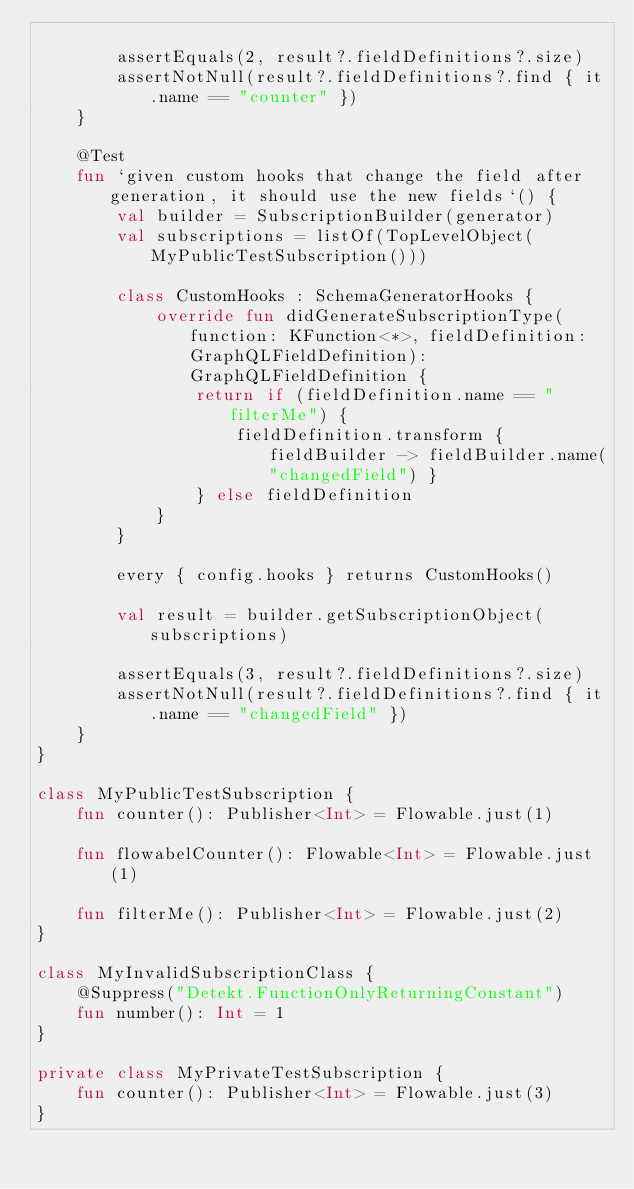<code> <loc_0><loc_0><loc_500><loc_500><_Kotlin_>
        assertEquals(2, result?.fieldDefinitions?.size)
        assertNotNull(result?.fieldDefinitions?.find { it.name == "counter" })
    }

    @Test
    fun `given custom hooks that change the field after generation, it should use the new fields`() {
        val builder = SubscriptionBuilder(generator)
        val subscriptions = listOf(TopLevelObject(MyPublicTestSubscription()))

        class CustomHooks : SchemaGeneratorHooks {
            override fun didGenerateSubscriptionType(function: KFunction<*>, fieldDefinition: GraphQLFieldDefinition): GraphQLFieldDefinition {
                return if (fieldDefinition.name == "filterMe") {
                    fieldDefinition.transform { fieldBuilder -> fieldBuilder.name("changedField") }
                } else fieldDefinition
            }
        }

        every { config.hooks } returns CustomHooks()

        val result = builder.getSubscriptionObject(subscriptions)

        assertEquals(3, result?.fieldDefinitions?.size)
        assertNotNull(result?.fieldDefinitions?.find { it.name == "changedField" })
    }
}

class MyPublicTestSubscription {
    fun counter(): Publisher<Int> = Flowable.just(1)

    fun flowabelCounter(): Flowable<Int> = Flowable.just(1)

    fun filterMe(): Publisher<Int> = Flowable.just(2)
}

class MyInvalidSubscriptionClass {
    @Suppress("Detekt.FunctionOnlyReturningConstant")
    fun number(): Int = 1
}

private class MyPrivateTestSubscription {
    fun counter(): Publisher<Int> = Flowable.just(3)
}
</code> 